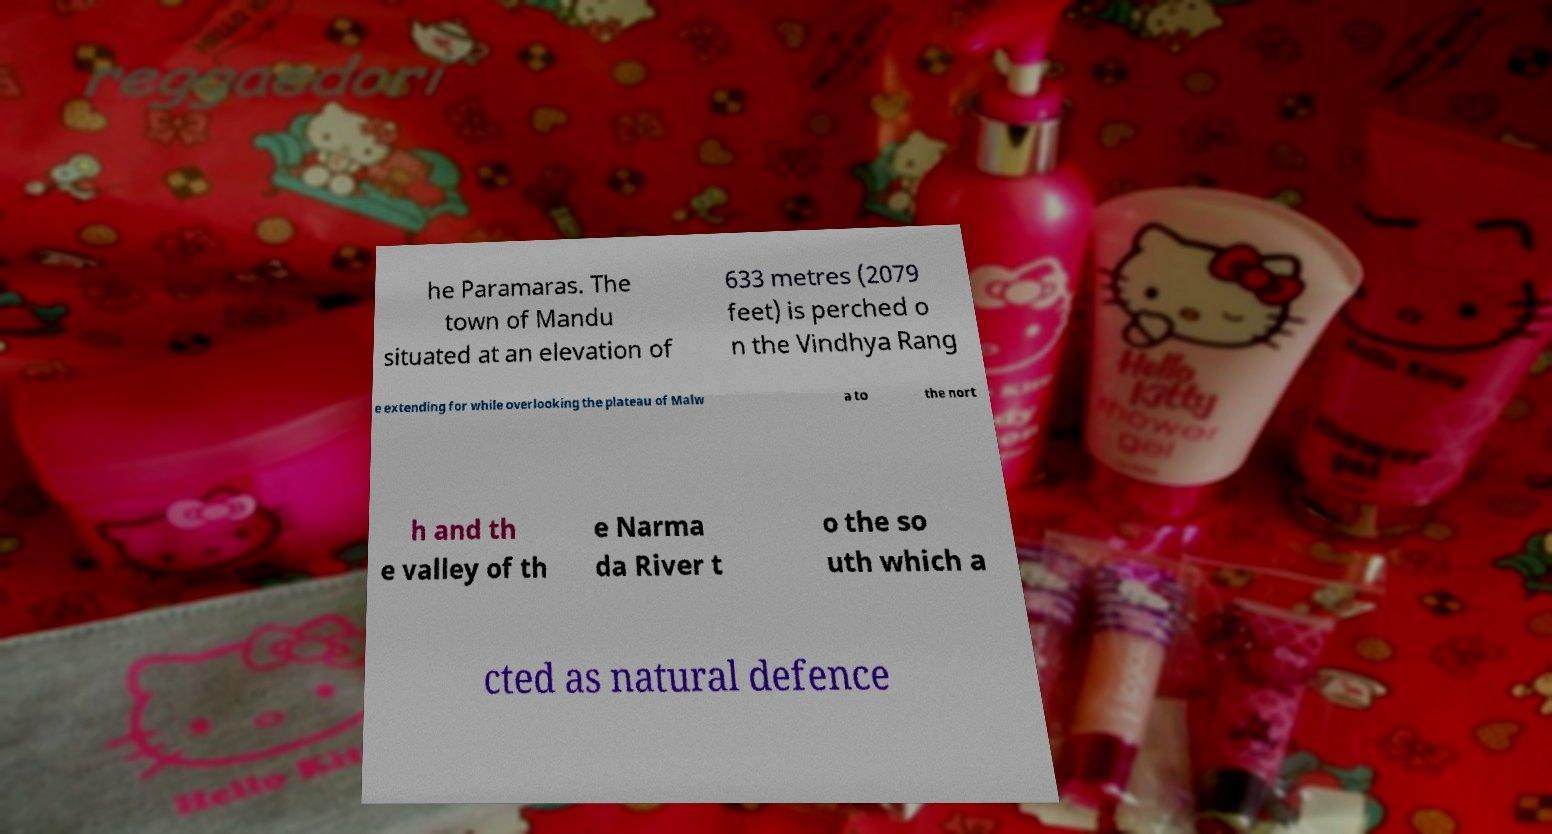Please read and relay the text visible in this image. What does it say? he Paramaras. The town of Mandu situated at an elevation of 633 metres (2079 feet) is perched o n the Vindhya Rang e extending for while overlooking the plateau of Malw a to the nort h and th e valley of th e Narma da River t o the so uth which a cted as natural defence 